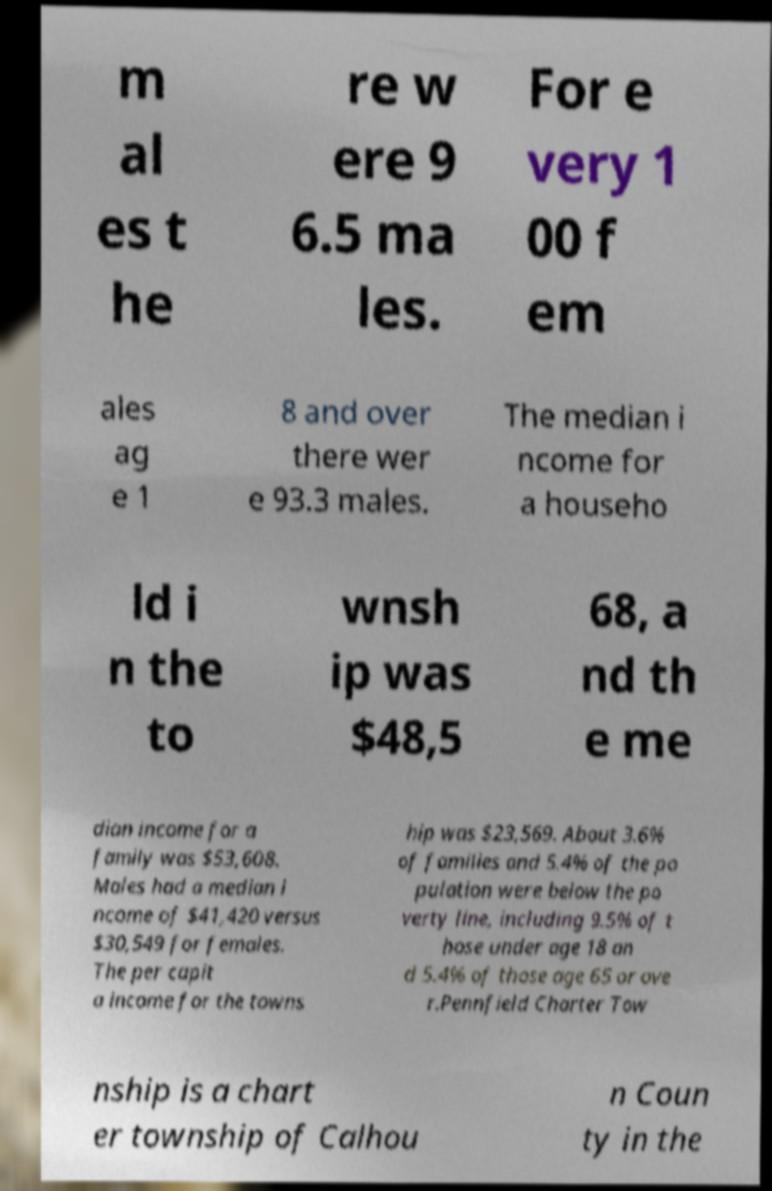Please read and relay the text visible in this image. What does it say? m al es t he re w ere 9 6.5 ma les. For e very 1 00 f em ales ag e 1 8 and over there wer e 93.3 males. The median i ncome for a househo ld i n the to wnsh ip was $48,5 68, a nd th e me dian income for a family was $53,608. Males had a median i ncome of $41,420 versus $30,549 for females. The per capit a income for the towns hip was $23,569. About 3.6% of families and 5.4% of the po pulation were below the po verty line, including 9.5% of t hose under age 18 an d 5.4% of those age 65 or ove r.Pennfield Charter Tow nship is a chart er township of Calhou n Coun ty in the 